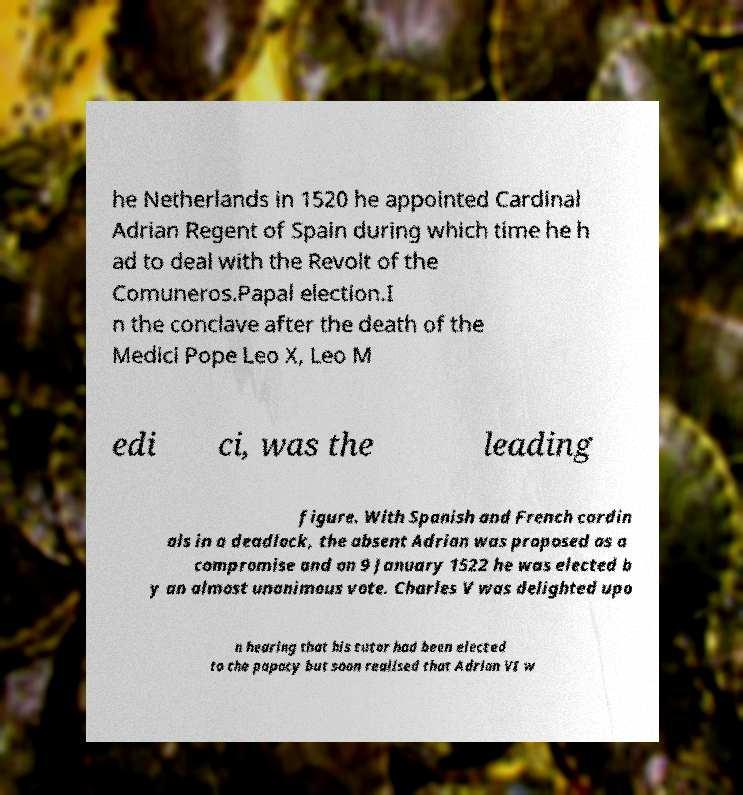Please identify and transcribe the text found in this image. he Netherlands in 1520 he appointed Cardinal Adrian Regent of Spain during which time he h ad to deal with the Revolt of the Comuneros.Papal election.I n the conclave after the death of the Medici Pope Leo X, Leo M edi ci, was the leading figure. With Spanish and French cardin als in a deadlock, the absent Adrian was proposed as a compromise and on 9 January 1522 he was elected b y an almost unanimous vote. Charles V was delighted upo n hearing that his tutor had been elected to the papacy but soon realised that Adrian VI w 